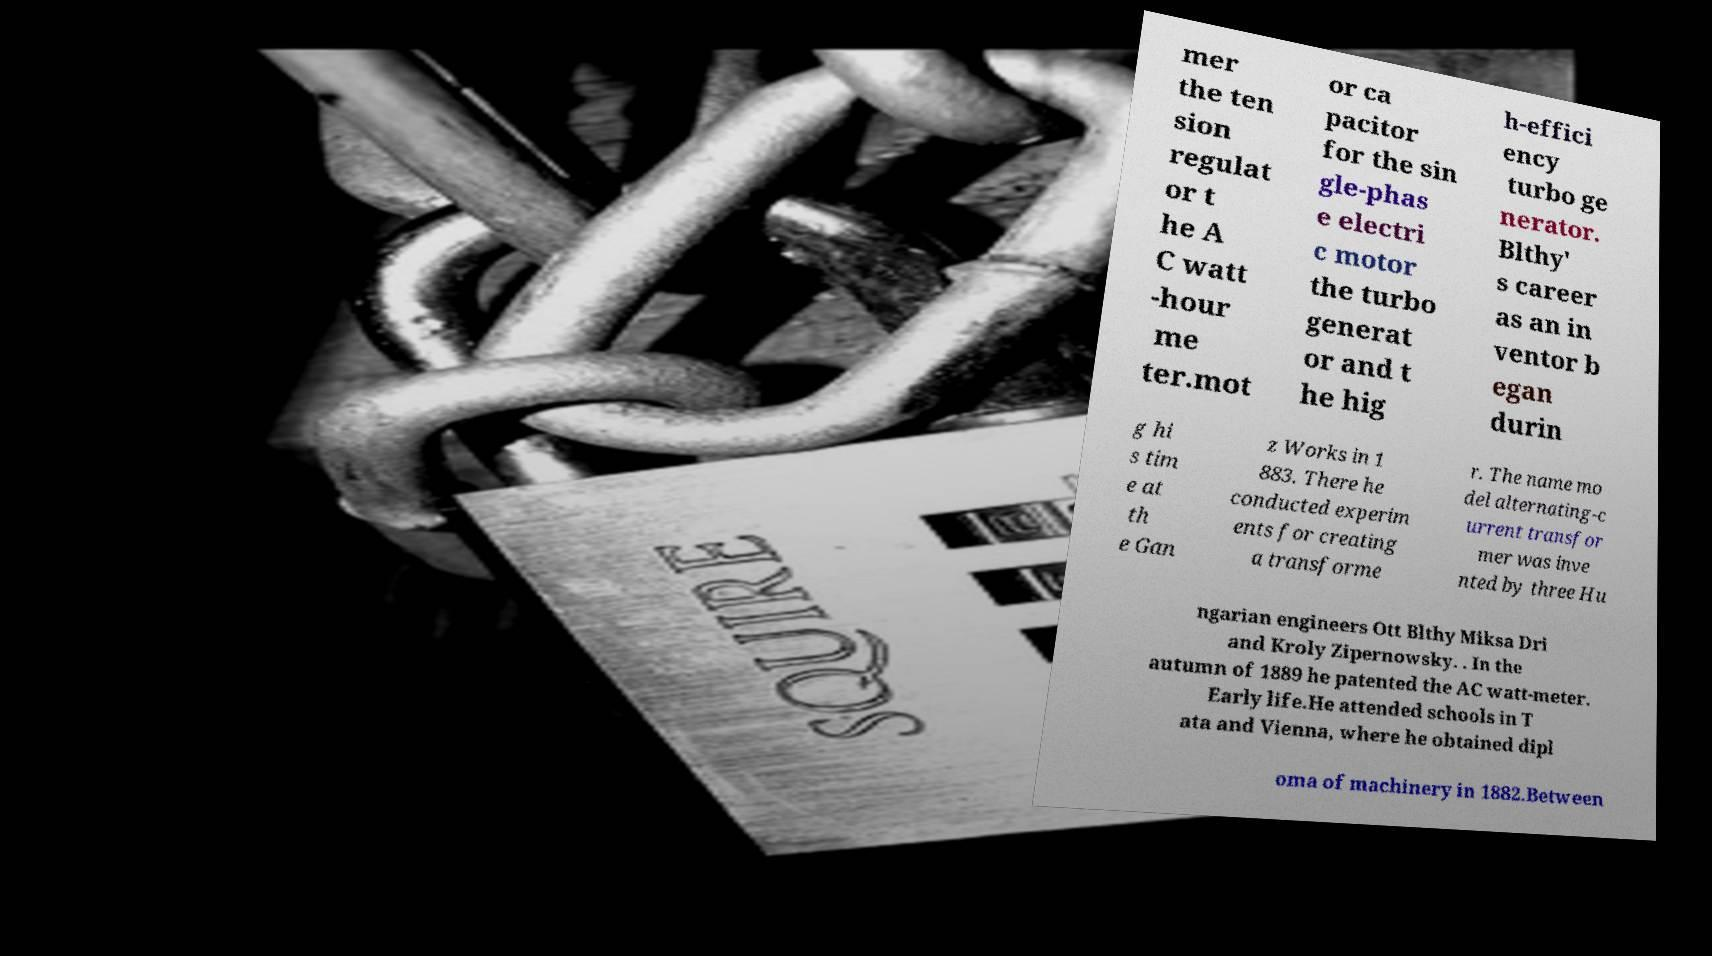Could you extract and type out the text from this image? mer the ten sion regulat or t he A C watt -hour me ter.mot or ca pacitor for the sin gle-phas e electri c motor the turbo generat or and t he hig h-effici ency turbo ge nerator. Blthy' s career as an in ventor b egan durin g hi s tim e at th e Gan z Works in 1 883. There he conducted experim ents for creating a transforme r. The name mo del alternating-c urrent transfor mer was inve nted by three Hu ngarian engineers Ott Blthy Miksa Dri and Kroly Zipernowsky. . In the autumn of 1889 he patented the AC watt-meter. Early life.He attended schools in T ata and Vienna, where he obtained dipl oma of machinery in 1882.Between 